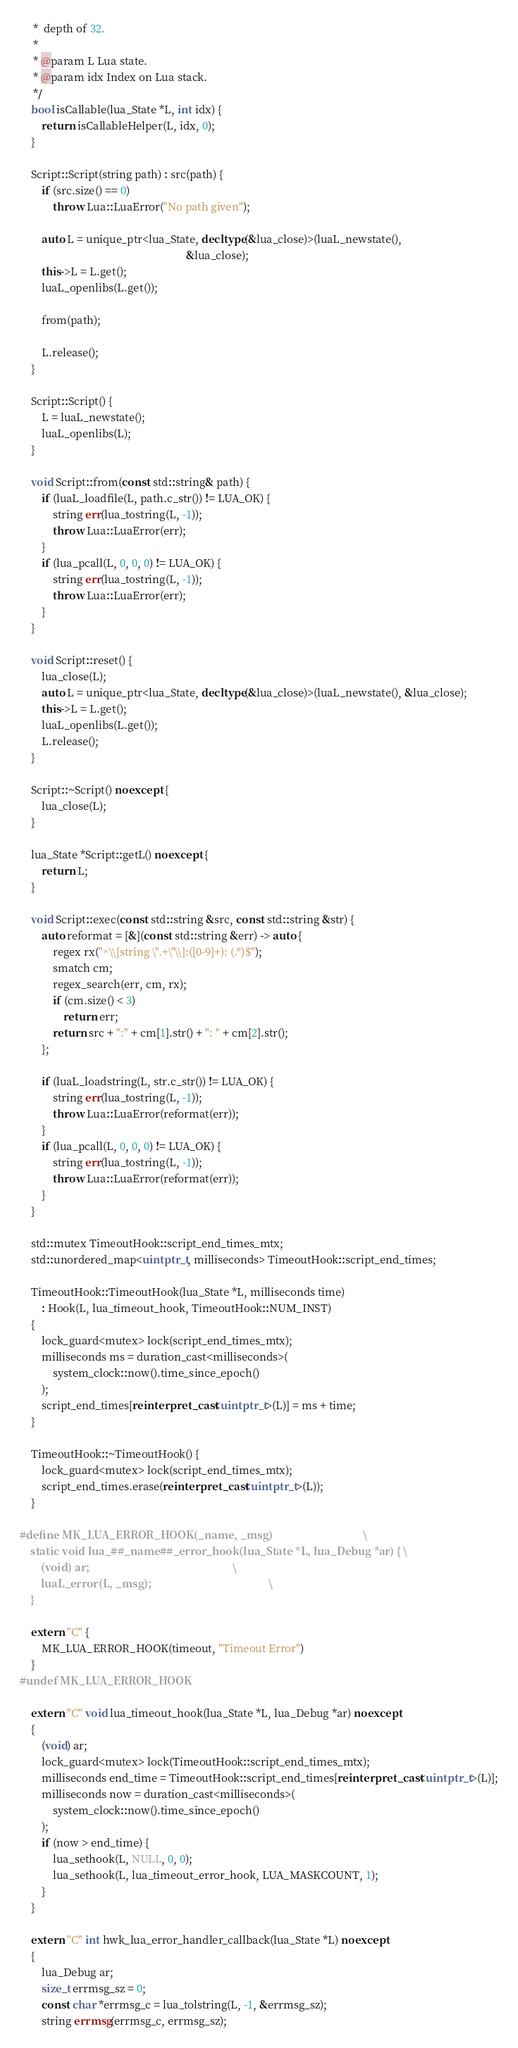Convert code to text. <code><loc_0><loc_0><loc_500><loc_500><_C++_>     *  depth of 32.
     *
     * @param L Lua state.
     * @param idx Index on Lua stack.
     */
    bool isCallable(lua_State *L, int idx) {
        return isCallableHelper(L, idx, 0);
    }

    Script::Script(string path) : src(path) {
        if (src.size() == 0)
            throw Lua::LuaError("No path given");

        auto L = unique_ptr<lua_State, decltype(&lua_close)>(luaL_newstate(),
                                                             &lua_close);
        this->L = L.get();
        luaL_openlibs(L.get());

        from(path);

        L.release();
    }

    Script::Script() {
        L = luaL_newstate();
        luaL_openlibs(L);
    }

    void Script::from(const std::string& path) {
        if (luaL_loadfile(L, path.c_str()) != LUA_OK) {
            string err(lua_tostring(L, -1));
            throw Lua::LuaError(err);
        }
        if (lua_pcall(L, 0, 0, 0) != LUA_OK) {
            string err(lua_tostring(L, -1));
            throw Lua::LuaError(err);
        }
    }

    void Script::reset() {
        lua_close(L);
        auto L = unique_ptr<lua_State, decltype(&lua_close)>(luaL_newstate(), &lua_close);
        this->L = L.get();
        luaL_openlibs(L.get());
        L.release();
    }

    Script::~Script() noexcept {
        lua_close(L);
    }

    lua_State *Script::getL() noexcept {
        return L;
    }

    void Script::exec(const std::string &src, const std::string &str) {
        auto reformat = [&](const std::string &err) -> auto {
            regex rx("^\\[string \".+\"\\]:([0-9]+): (.*)$");
            smatch cm;
            regex_search(err, cm, rx);
            if (cm.size() < 3)
                return err;
            return src + ":" + cm[1].str() + ": " + cm[2].str();
        };

        if (luaL_loadstring(L, str.c_str()) != LUA_OK) {
            string err(lua_tostring(L, -1));
            throw Lua::LuaError(reformat(err));
        }
        if (lua_pcall(L, 0, 0, 0) != LUA_OK) {
            string err(lua_tostring(L, -1));
            throw Lua::LuaError(reformat(err));
        }
    }

    std::mutex TimeoutHook::script_end_times_mtx;
    std::unordered_map<uintptr_t, milliseconds> TimeoutHook::script_end_times;

    TimeoutHook::TimeoutHook(lua_State *L, milliseconds time)
        : Hook(L, lua_timeout_hook, TimeoutHook::NUM_INST)
    {
        lock_guard<mutex> lock(script_end_times_mtx);
        milliseconds ms = duration_cast<milliseconds>(
            system_clock::now().time_since_epoch()
        );
        script_end_times[reinterpret_cast<uintptr_t>(L)] = ms + time;
    }

    TimeoutHook::~TimeoutHook() {
        lock_guard<mutex> lock(script_end_times_mtx);
        script_end_times.erase(reinterpret_cast<uintptr_t>(L));
    }

#define MK_LUA_ERROR_HOOK(_name, _msg)                                  \
    static void lua_##_name##_error_hook(lua_State *L, lua_Debug *ar) { \
        (void) ar;                                                      \
        luaL_error(L, _msg);                                            \
    }

    extern "C" {
        MK_LUA_ERROR_HOOK(timeout, "Timeout Error")
    }
#undef MK_LUA_ERROR_HOOK

    extern "C" void lua_timeout_hook(lua_State *L, lua_Debug *ar) noexcept
    {
        (void) ar;
        lock_guard<mutex> lock(TimeoutHook::script_end_times_mtx);
        milliseconds end_time = TimeoutHook::script_end_times[reinterpret_cast<uintptr_t>(L)];
        milliseconds now = duration_cast<milliseconds>(
            system_clock::now().time_since_epoch()
        );
        if (now > end_time) {
            lua_sethook(L, NULL, 0, 0);
            lua_sethook(L, lua_timeout_error_hook, LUA_MASKCOUNT, 1);
        }
    }

    extern "C" int hwk_lua_error_handler_callback(lua_State *L) noexcept
    {
        lua_Debug ar;
        size_t errmsg_sz = 0;
        const char *errmsg_c = lua_tolstring(L, -1, &errmsg_sz);
        string errmsg(errmsg_c, errmsg_sz);</code> 